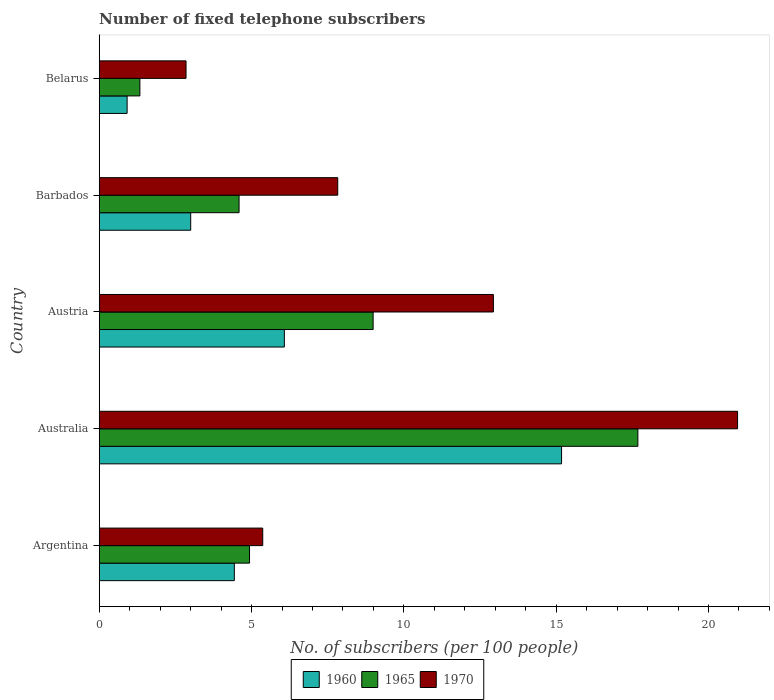How many different coloured bars are there?
Provide a succinct answer. 3. How many groups of bars are there?
Your response must be concise. 5. Are the number of bars per tick equal to the number of legend labels?
Ensure brevity in your answer.  Yes. What is the label of the 4th group of bars from the top?
Your answer should be very brief. Australia. What is the number of fixed telephone subscribers in 1965 in Austria?
Offer a terse response. 8.99. Across all countries, what is the maximum number of fixed telephone subscribers in 1970?
Your answer should be compact. 20.95. Across all countries, what is the minimum number of fixed telephone subscribers in 1965?
Offer a terse response. 1.33. In which country was the number of fixed telephone subscribers in 1970 maximum?
Your answer should be very brief. Australia. In which country was the number of fixed telephone subscribers in 1965 minimum?
Your response must be concise. Belarus. What is the total number of fixed telephone subscribers in 1960 in the graph?
Keep it short and to the point. 29.61. What is the difference between the number of fixed telephone subscribers in 1965 in Argentina and that in Austria?
Keep it short and to the point. -4.06. What is the difference between the number of fixed telephone subscribers in 1960 in Argentina and the number of fixed telephone subscribers in 1965 in Austria?
Your answer should be compact. -4.56. What is the average number of fixed telephone subscribers in 1960 per country?
Offer a terse response. 5.92. What is the difference between the number of fixed telephone subscribers in 1960 and number of fixed telephone subscribers in 1970 in Austria?
Make the answer very short. -6.86. In how many countries, is the number of fixed telephone subscribers in 1965 greater than 4 ?
Make the answer very short. 4. What is the ratio of the number of fixed telephone subscribers in 1960 in Barbados to that in Belarus?
Keep it short and to the point. 3.28. Is the number of fixed telephone subscribers in 1960 in Argentina less than that in Austria?
Provide a short and direct response. Yes. Is the difference between the number of fixed telephone subscribers in 1960 in Argentina and Belarus greater than the difference between the number of fixed telephone subscribers in 1970 in Argentina and Belarus?
Offer a very short reply. Yes. What is the difference between the highest and the second highest number of fixed telephone subscribers in 1970?
Ensure brevity in your answer.  8.02. What is the difference between the highest and the lowest number of fixed telephone subscribers in 1960?
Ensure brevity in your answer.  14.26. What does the 3rd bar from the bottom in Austria represents?
Make the answer very short. 1970. What is the difference between two consecutive major ticks on the X-axis?
Provide a short and direct response. 5. Are the values on the major ticks of X-axis written in scientific E-notation?
Ensure brevity in your answer.  No. Does the graph contain grids?
Your answer should be very brief. No. What is the title of the graph?
Give a very brief answer. Number of fixed telephone subscribers. What is the label or title of the X-axis?
Keep it short and to the point. No. of subscribers (per 100 people). What is the No. of subscribers (per 100 people) of 1960 in Argentina?
Ensure brevity in your answer.  4.43. What is the No. of subscribers (per 100 people) in 1965 in Argentina?
Provide a short and direct response. 4.93. What is the No. of subscribers (per 100 people) of 1970 in Argentina?
Your response must be concise. 5.37. What is the No. of subscribers (per 100 people) in 1960 in Australia?
Provide a succinct answer. 15.18. What is the No. of subscribers (per 100 people) of 1965 in Australia?
Provide a short and direct response. 17.68. What is the No. of subscribers (per 100 people) of 1970 in Australia?
Provide a succinct answer. 20.95. What is the No. of subscribers (per 100 people) of 1960 in Austria?
Give a very brief answer. 6.08. What is the No. of subscribers (per 100 people) in 1965 in Austria?
Offer a terse response. 8.99. What is the No. of subscribers (per 100 people) of 1970 in Austria?
Give a very brief answer. 12.94. What is the No. of subscribers (per 100 people) in 1960 in Barbados?
Your answer should be very brief. 3. What is the No. of subscribers (per 100 people) in 1965 in Barbados?
Your answer should be very brief. 4.59. What is the No. of subscribers (per 100 people) of 1970 in Barbados?
Offer a terse response. 7.83. What is the No. of subscribers (per 100 people) of 1960 in Belarus?
Your response must be concise. 0.92. What is the No. of subscribers (per 100 people) in 1965 in Belarus?
Your response must be concise. 1.33. What is the No. of subscribers (per 100 people) of 1970 in Belarus?
Ensure brevity in your answer.  2.85. Across all countries, what is the maximum No. of subscribers (per 100 people) of 1960?
Offer a terse response. 15.18. Across all countries, what is the maximum No. of subscribers (per 100 people) in 1965?
Offer a terse response. 17.68. Across all countries, what is the maximum No. of subscribers (per 100 people) of 1970?
Keep it short and to the point. 20.95. Across all countries, what is the minimum No. of subscribers (per 100 people) in 1960?
Your answer should be very brief. 0.92. Across all countries, what is the minimum No. of subscribers (per 100 people) in 1965?
Offer a terse response. 1.33. Across all countries, what is the minimum No. of subscribers (per 100 people) of 1970?
Make the answer very short. 2.85. What is the total No. of subscribers (per 100 people) of 1960 in the graph?
Keep it short and to the point. 29.61. What is the total No. of subscribers (per 100 people) of 1965 in the graph?
Make the answer very short. 37.53. What is the total No. of subscribers (per 100 people) of 1970 in the graph?
Your response must be concise. 49.94. What is the difference between the No. of subscribers (per 100 people) in 1960 in Argentina and that in Australia?
Ensure brevity in your answer.  -10.74. What is the difference between the No. of subscribers (per 100 people) of 1965 in Argentina and that in Australia?
Your answer should be compact. -12.75. What is the difference between the No. of subscribers (per 100 people) in 1970 in Argentina and that in Australia?
Provide a succinct answer. -15.59. What is the difference between the No. of subscribers (per 100 people) of 1960 in Argentina and that in Austria?
Give a very brief answer. -1.64. What is the difference between the No. of subscribers (per 100 people) in 1965 in Argentina and that in Austria?
Keep it short and to the point. -4.06. What is the difference between the No. of subscribers (per 100 people) of 1970 in Argentina and that in Austria?
Your answer should be compact. -7.57. What is the difference between the No. of subscribers (per 100 people) of 1960 in Argentina and that in Barbados?
Offer a terse response. 1.43. What is the difference between the No. of subscribers (per 100 people) of 1965 in Argentina and that in Barbados?
Offer a terse response. 0.34. What is the difference between the No. of subscribers (per 100 people) of 1970 in Argentina and that in Barbados?
Your answer should be very brief. -2.46. What is the difference between the No. of subscribers (per 100 people) in 1960 in Argentina and that in Belarus?
Ensure brevity in your answer.  3.52. What is the difference between the No. of subscribers (per 100 people) in 1965 in Argentina and that in Belarus?
Provide a succinct answer. 3.6. What is the difference between the No. of subscribers (per 100 people) of 1970 in Argentina and that in Belarus?
Your answer should be very brief. 2.52. What is the difference between the No. of subscribers (per 100 people) in 1960 in Australia and that in Austria?
Make the answer very short. 9.1. What is the difference between the No. of subscribers (per 100 people) in 1965 in Australia and that in Austria?
Give a very brief answer. 8.69. What is the difference between the No. of subscribers (per 100 people) of 1970 in Australia and that in Austria?
Keep it short and to the point. 8.02. What is the difference between the No. of subscribers (per 100 people) of 1960 in Australia and that in Barbados?
Give a very brief answer. 12.17. What is the difference between the No. of subscribers (per 100 people) in 1965 in Australia and that in Barbados?
Your response must be concise. 13.09. What is the difference between the No. of subscribers (per 100 people) of 1970 in Australia and that in Barbados?
Your answer should be compact. 13.12. What is the difference between the No. of subscribers (per 100 people) in 1960 in Australia and that in Belarus?
Offer a very short reply. 14.26. What is the difference between the No. of subscribers (per 100 people) of 1965 in Australia and that in Belarus?
Ensure brevity in your answer.  16.35. What is the difference between the No. of subscribers (per 100 people) in 1970 in Australia and that in Belarus?
Your response must be concise. 18.1. What is the difference between the No. of subscribers (per 100 people) of 1960 in Austria and that in Barbados?
Your answer should be very brief. 3.07. What is the difference between the No. of subscribers (per 100 people) in 1965 in Austria and that in Barbados?
Your response must be concise. 4.4. What is the difference between the No. of subscribers (per 100 people) in 1970 in Austria and that in Barbados?
Give a very brief answer. 5.11. What is the difference between the No. of subscribers (per 100 people) of 1960 in Austria and that in Belarus?
Your response must be concise. 5.16. What is the difference between the No. of subscribers (per 100 people) of 1965 in Austria and that in Belarus?
Offer a terse response. 7.66. What is the difference between the No. of subscribers (per 100 people) of 1970 in Austria and that in Belarus?
Ensure brevity in your answer.  10.09. What is the difference between the No. of subscribers (per 100 people) of 1960 in Barbados and that in Belarus?
Offer a very short reply. 2.09. What is the difference between the No. of subscribers (per 100 people) of 1965 in Barbados and that in Belarus?
Ensure brevity in your answer.  3.26. What is the difference between the No. of subscribers (per 100 people) of 1970 in Barbados and that in Belarus?
Offer a terse response. 4.98. What is the difference between the No. of subscribers (per 100 people) of 1960 in Argentina and the No. of subscribers (per 100 people) of 1965 in Australia?
Provide a short and direct response. -13.25. What is the difference between the No. of subscribers (per 100 people) in 1960 in Argentina and the No. of subscribers (per 100 people) in 1970 in Australia?
Give a very brief answer. -16.52. What is the difference between the No. of subscribers (per 100 people) of 1965 in Argentina and the No. of subscribers (per 100 people) of 1970 in Australia?
Give a very brief answer. -16.02. What is the difference between the No. of subscribers (per 100 people) of 1960 in Argentina and the No. of subscribers (per 100 people) of 1965 in Austria?
Give a very brief answer. -4.56. What is the difference between the No. of subscribers (per 100 people) in 1960 in Argentina and the No. of subscribers (per 100 people) in 1970 in Austria?
Make the answer very short. -8.5. What is the difference between the No. of subscribers (per 100 people) of 1965 in Argentina and the No. of subscribers (per 100 people) of 1970 in Austria?
Your response must be concise. -8. What is the difference between the No. of subscribers (per 100 people) in 1960 in Argentina and the No. of subscribers (per 100 people) in 1965 in Barbados?
Provide a short and direct response. -0.16. What is the difference between the No. of subscribers (per 100 people) of 1960 in Argentina and the No. of subscribers (per 100 people) of 1970 in Barbados?
Your answer should be very brief. -3.39. What is the difference between the No. of subscribers (per 100 people) of 1965 in Argentina and the No. of subscribers (per 100 people) of 1970 in Barbados?
Keep it short and to the point. -2.9. What is the difference between the No. of subscribers (per 100 people) of 1960 in Argentina and the No. of subscribers (per 100 people) of 1970 in Belarus?
Provide a succinct answer. 1.59. What is the difference between the No. of subscribers (per 100 people) of 1965 in Argentina and the No. of subscribers (per 100 people) of 1970 in Belarus?
Your answer should be compact. 2.08. What is the difference between the No. of subscribers (per 100 people) of 1960 in Australia and the No. of subscribers (per 100 people) of 1965 in Austria?
Give a very brief answer. 6.19. What is the difference between the No. of subscribers (per 100 people) in 1960 in Australia and the No. of subscribers (per 100 people) in 1970 in Austria?
Provide a short and direct response. 2.24. What is the difference between the No. of subscribers (per 100 people) in 1965 in Australia and the No. of subscribers (per 100 people) in 1970 in Austria?
Offer a terse response. 4.74. What is the difference between the No. of subscribers (per 100 people) of 1960 in Australia and the No. of subscribers (per 100 people) of 1965 in Barbados?
Offer a very short reply. 10.59. What is the difference between the No. of subscribers (per 100 people) in 1960 in Australia and the No. of subscribers (per 100 people) in 1970 in Barbados?
Provide a succinct answer. 7.35. What is the difference between the No. of subscribers (per 100 people) in 1965 in Australia and the No. of subscribers (per 100 people) in 1970 in Barbados?
Give a very brief answer. 9.85. What is the difference between the No. of subscribers (per 100 people) in 1960 in Australia and the No. of subscribers (per 100 people) in 1965 in Belarus?
Provide a short and direct response. 13.84. What is the difference between the No. of subscribers (per 100 people) of 1960 in Australia and the No. of subscribers (per 100 people) of 1970 in Belarus?
Keep it short and to the point. 12.33. What is the difference between the No. of subscribers (per 100 people) of 1965 in Australia and the No. of subscribers (per 100 people) of 1970 in Belarus?
Your answer should be very brief. 14.83. What is the difference between the No. of subscribers (per 100 people) of 1960 in Austria and the No. of subscribers (per 100 people) of 1965 in Barbados?
Keep it short and to the point. 1.49. What is the difference between the No. of subscribers (per 100 people) of 1960 in Austria and the No. of subscribers (per 100 people) of 1970 in Barbados?
Provide a succinct answer. -1.75. What is the difference between the No. of subscribers (per 100 people) in 1965 in Austria and the No. of subscribers (per 100 people) in 1970 in Barbados?
Offer a very short reply. 1.16. What is the difference between the No. of subscribers (per 100 people) of 1960 in Austria and the No. of subscribers (per 100 people) of 1965 in Belarus?
Keep it short and to the point. 4.74. What is the difference between the No. of subscribers (per 100 people) in 1960 in Austria and the No. of subscribers (per 100 people) in 1970 in Belarus?
Give a very brief answer. 3.23. What is the difference between the No. of subscribers (per 100 people) in 1965 in Austria and the No. of subscribers (per 100 people) in 1970 in Belarus?
Provide a succinct answer. 6.14. What is the difference between the No. of subscribers (per 100 people) of 1960 in Barbados and the No. of subscribers (per 100 people) of 1965 in Belarus?
Offer a terse response. 1.67. What is the difference between the No. of subscribers (per 100 people) of 1960 in Barbados and the No. of subscribers (per 100 people) of 1970 in Belarus?
Keep it short and to the point. 0.15. What is the difference between the No. of subscribers (per 100 people) of 1965 in Barbados and the No. of subscribers (per 100 people) of 1970 in Belarus?
Make the answer very short. 1.74. What is the average No. of subscribers (per 100 people) of 1960 per country?
Your answer should be compact. 5.92. What is the average No. of subscribers (per 100 people) of 1965 per country?
Provide a succinct answer. 7.51. What is the average No. of subscribers (per 100 people) of 1970 per country?
Provide a short and direct response. 9.99. What is the difference between the No. of subscribers (per 100 people) of 1960 and No. of subscribers (per 100 people) of 1965 in Argentina?
Ensure brevity in your answer.  -0.5. What is the difference between the No. of subscribers (per 100 people) in 1960 and No. of subscribers (per 100 people) in 1970 in Argentina?
Ensure brevity in your answer.  -0.93. What is the difference between the No. of subscribers (per 100 people) of 1965 and No. of subscribers (per 100 people) of 1970 in Argentina?
Your answer should be compact. -0.43. What is the difference between the No. of subscribers (per 100 people) of 1960 and No. of subscribers (per 100 people) of 1965 in Australia?
Your answer should be very brief. -2.51. What is the difference between the No. of subscribers (per 100 people) in 1960 and No. of subscribers (per 100 people) in 1970 in Australia?
Provide a succinct answer. -5.78. What is the difference between the No. of subscribers (per 100 people) in 1965 and No. of subscribers (per 100 people) in 1970 in Australia?
Offer a terse response. -3.27. What is the difference between the No. of subscribers (per 100 people) in 1960 and No. of subscribers (per 100 people) in 1965 in Austria?
Provide a short and direct response. -2.91. What is the difference between the No. of subscribers (per 100 people) in 1960 and No. of subscribers (per 100 people) in 1970 in Austria?
Provide a short and direct response. -6.86. What is the difference between the No. of subscribers (per 100 people) of 1965 and No. of subscribers (per 100 people) of 1970 in Austria?
Give a very brief answer. -3.95. What is the difference between the No. of subscribers (per 100 people) in 1960 and No. of subscribers (per 100 people) in 1965 in Barbados?
Ensure brevity in your answer.  -1.59. What is the difference between the No. of subscribers (per 100 people) of 1960 and No. of subscribers (per 100 people) of 1970 in Barbados?
Your answer should be very brief. -4.83. What is the difference between the No. of subscribers (per 100 people) of 1965 and No. of subscribers (per 100 people) of 1970 in Barbados?
Provide a succinct answer. -3.24. What is the difference between the No. of subscribers (per 100 people) of 1960 and No. of subscribers (per 100 people) of 1965 in Belarus?
Your answer should be very brief. -0.42. What is the difference between the No. of subscribers (per 100 people) of 1960 and No. of subscribers (per 100 people) of 1970 in Belarus?
Give a very brief answer. -1.93. What is the difference between the No. of subscribers (per 100 people) in 1965 and No. of subscribers (per 100 people) in 1970 in Belarus?
Offer a very short reply. -1.51. What is the ratio of the No. of subscribers (per 100 people) of 1960 in Argentina to that in Australia?
Offer a terse response. 0.29. What is the ratio of the No. of subscribers (per 100 people) in 1965 in Argentina to that in Australia?
Ensure brevity in your answer.  0.28. What is the ratio of the No. of subscribers (per 100 people) of 1970 in Argentina to that in Australia?
Your answer should be compact. 0.26. What is the ratio of the No. of subscribers (per 100 people) of 1960 in Argentina to that in Austria?
Provide a succinct answer. 0.73. What is the ratio of the No. of subscribers (per 100 people) in 1965 in Argentina to that in Austria?
Offer a terse response. 0.55. What is the ratio of the No. of subscribers (per 100 people) of 1970 in Argentina to that in Austria?
Offer a very short reply. 0.41. What is the ratio of the No. of subscribers (per 100 people) of 1960 in Argentina to that in Barbados?
Keep it short and to the point. 1.48. What is the ratio of the No. of subscribers (per 100 people) of 1965 in Argentina to that in Barbados?
Offer a terse response. 1.07. What is the ratio of the No. of subscribers (per 100 people) in 1970 in Argentina to that in Barbados?
Make the answer very short. 0.69. What is the ratio of the No. of subscribers (per 100 people) in 1960 in Argentina to that in Belarus?
Make the answer very short. 4.84. What is the ratio of the No. of subscribers (per 100 people) in 1965 in Argentina to that in Belarus?
Offer a very short reply. 3.7. What is the ratio of the No. of subscribers (per 100 people) of 1970 in Argentina to that in Belarus?
Offer a very short reply. 1.88. What is the ratio of the No. of subscribers (per 100 people) in 1960 in Australia to that in Austria?
Keep it short and to the point. 2.5. What is the ratio of the No. of subscribers (per 100 people) in 1965 in Australia to that in Austria?
Your answer should be compact. 1.97. What is the ratio of the No. of subscribers (per 100 people) in 1970 in Australia to that in Austria?
Offer a terse response. 1.62. What is the ratio of the No. of subscribers (per 100 people) of 1960 in Australia to that in Barbados?
Make the answer very short. 5.05. What is the ratio of the No. of subscribers (per 100 people) in 1965 in Australia to that in Barbados?
Provide a succinct answer. 3.85. What is the ratio of the No. of subscribers (per 100 people) in 1970 in Australia to that in Barbados?
Offer a terse response. 2.68. What is the ratio of the No. of subscribers (per 100 people) of 1960 in Australia to that in Belarus?
Your answer should be very brief. 16.57. What is the ratio of the No. of subscribers (per 100 people) of 1965 in Australia to that in Belarus?
Your response must be concise. 13.24. What is the ratio of the No. of subscribers (per 100 people) of 1970 in Australia to that in Belarus?
Your answer should be compact. 7.35. What is the ratio of the No. of subscribers (per 100 people) of 1960 in Austria to that in Barbados?
Make the answer very short. 2.02. What is the ratio of the No. of subscribers (per 100 people) in 1965 in Austria to that in Barbados?
Ensure brevity in your answer.  1.96. What is the ratio of the No. of subscribers (per 100 people) of 1970 in Austria to that in Barbados?
Give a very brief answer. 1.65. What is the ratio of the No. of subscribers (per 100 people) of 1960 in Austria to that in Belarus?
Provide a short and direct response. 6.64. What is the ratio of the No. of subscribers (per 100 people) in 1965 in Austria to that in Belarus?
Your answer should be compact. 6.73. What is the ratio of the No. of subscribers (per 100 people) of 1970 in Austria to that in Belarus?
Offer a very short reply. 4.54. What is the ratio of the No. of subscribers (per 100 people) in 1960 in Barbados to that in Belarus?
Keep it short and to the point. 3.28. What is the ratio of the No. of subscribers (per 100 people) of 1965 in Barbados to that in Belarus?
Your answer should be very brief. 3.44. What is the ratio of the No. of subscribers (per 100 people) of 1970 in Barbados to that in Belarus?
Provide a succinct answer. 2.75. What is the difference between the highest and the second highest No. of subscribers (per 100 people) in 1960?
Keep it short and to the point. 9.1. What is the difference between the highest and the second highest No. of subscribers (per 100 people) in 1965?
Offer a very short reply. 8.69. What is the difference between the highest and the second highest No. of subscribers (per 100 people) of 1970?
Provide a short and direct response. 8.02. What is the difference between the highest and the lowest No. of subscribers (per 100 people) in 1960?
Offer a terse response. 14.26. What is the difference between the highest and the lowest No. of subscribers (per 100 people) in 1965?
Offer a terse response. 16.35. What is the difference between the highest and the lowest No. of subscribers (per 100 people) of 1970?
Offer a terse response. 18.1. 